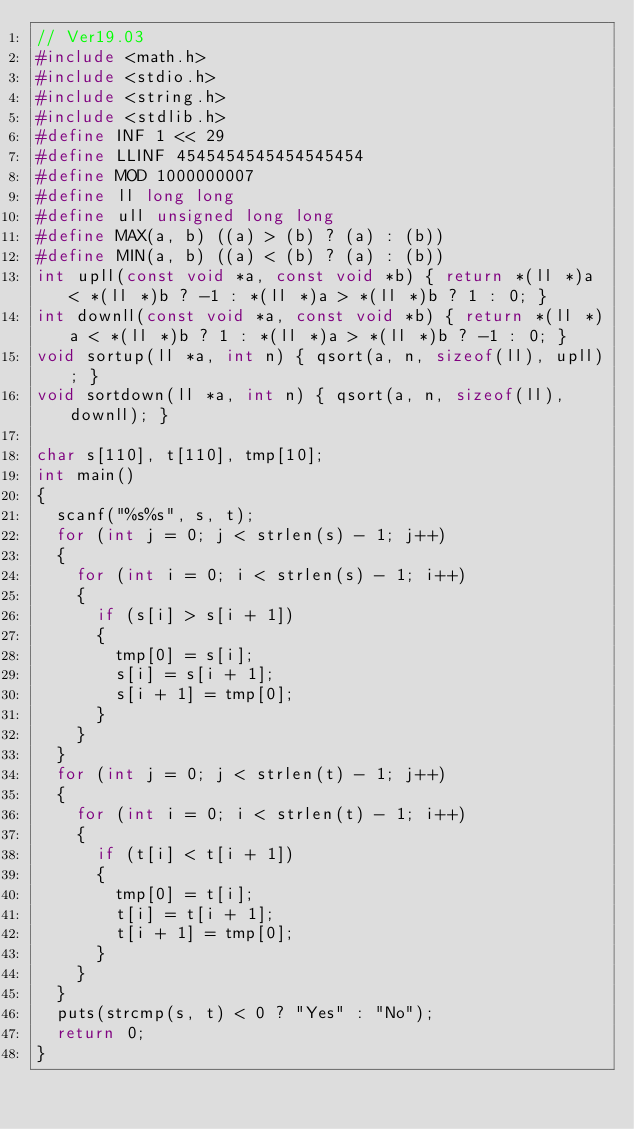<code> <loc_0><loc_0><loc_500><loc_500><_C_>// Ver19.03
#include <math.h>
#include <stdio.h>
#include <string.h>
#include <stdlib.h>
#define INF 1 << 29
#define LLINF 4545454545454545454
#define MOD 1000000007
#define ll long long
#define ull unsigned long long
#define MAX(a, b) ((a) > (b) ? (a) : (b))
#define MIN(a, b) ((a) < (b) ? (a) : (b))
int upll(const void *a, const void *b) { return *(ll *)a < *(ll *)b ? -1 : *(ll *)a > *(ll *)b ? 1 : 0; }
int downll(const void *a, const void *b) { return *(ll *)a < *(ll *)b ? 1 : *(ll *)a > *(ll *)b ? -1 : 0; }
void sortup(ll *a, int n) { qsort(a, n, sizeof(ll), upll); }
void sortdown(ll *a, int n) { qsort(a, n, sizeof(ll), downll); }

char s[110], t[110], tmp[10];
int main()
{
  scanf("%s%s", s, t);
  for (int j = 0; j < strlen(s) - 1; j++)
  {
    for (int i = 0; i < strlen(s) - 1; i++)
    {
      if (s[i] > s[i + 1])
      {
        tmp[0] = s[i];
        s[i] = s[i + 1];
        s[i + 1] = tmp[0];
      }
    }
  }
  for (int j = 0; j < strlen(t) - 1; j++)
  {
    for (int i = 0; i < strlen(t) - 1; i++)
    {
      if (t[i] < t[i + 1])
      {
        tmp[0] = t[i];
        t[i] = t[i + 1];
        t[i + 1] = tmp[0];
      }
    }
  }
  puts(strcmp(s, t) < 0 ? "Yes" : "No");
  return 0;
}</code> 